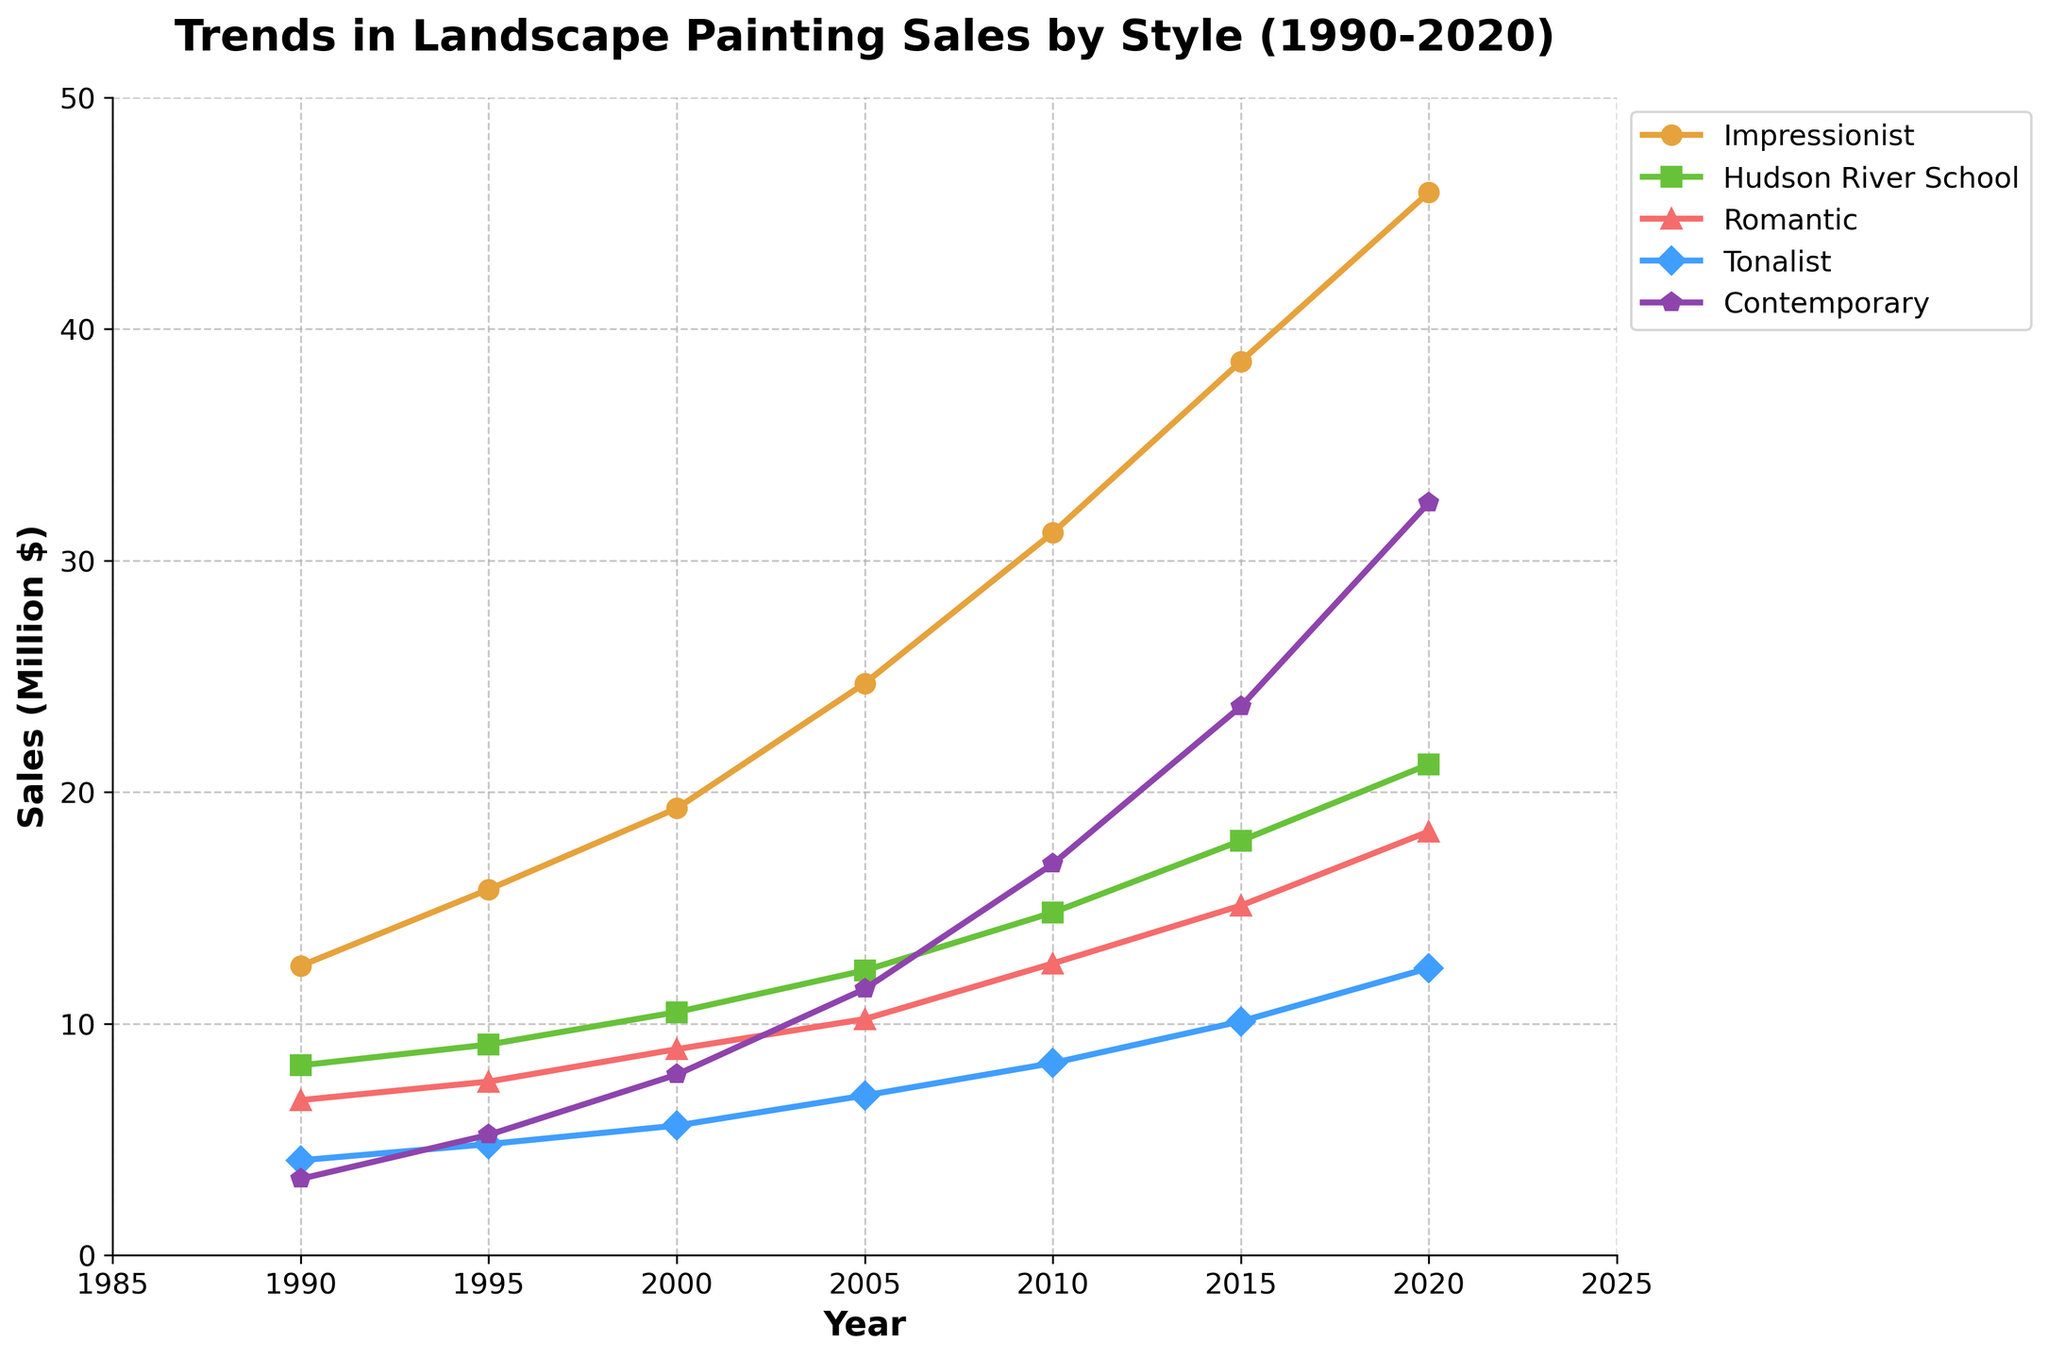What is the overall trend in sales for the Contemporary style from 1990 to 2020? From the figure, the line for Contemporary style shows a consistent upward trend from 1990 to 2020. This indicates that the sales for Contemporary landscape paintings have increased over the past three decades.
Answer: Increasing Which style had the highest sales in 2005? In the year 2005, the height of the Impressionist style line is the highest among all styles on the plot. This shows that Impressionist landscape paintings had the highest sales in that year.
Answer: Impressionist What is the difference in sales between the Hudson River School and Tonalist styles in 2015? For 2015, the sales for Hudson River School is approximately 17.9 million dollars, and for Tonalist, it is approximately 10.1 million dollars. The difference is 17.9 - 10.1 = 7.8 million dollars.
Answer: 7.8 million dollars Which style experienced the greatest increase in sales from 1990 to 2020? To find the greatest increase, subtract the 1990 values from the 2020 values for each style: Impressionist (45.9 - 12.5 = 33.4), Hudson River School (21.2 - 8.2 = 13.0), Romantic (18.3 - 6.7 = 11.6), Tonalist (12.4 - 4.1 = 8.3), Contemporary (32.5 - 3.3 = 29.2). The Impressionist style has the highest increase in sales with 33.4 million dollars.
Answer: Impressionist In which year do sales for the Tonalist style first exceed 10 million dollars? The Tonalist line exceeds the 10 million dollar mark slightly above the 10 million dollar line in the year 2015.
Answer: 2015 How do the sales of Romantic and Hudson River School styles compare in 2000? In the year 2000, the Romantic sales are approximately 8.9 million dollars and the Hudson River School sales are approximately 10.5 million dollars. The Hudson River School sales are higher than Romantic.
Answer: Hudson River School What are the average sales for the Romantic style over the three decades? The sales for Romantic style are 6.7, 7.5, 8.9, 10.2, 12.6, 15.1, and 18.3 over the years. Adding these values together gives 79.3, and dividing this sum by 7 (the number of years) results in approximately 11.3.
Answer: 11.3 million dollars Which three styles show the clearest upward trend over the period from 1990 to 2020? By examining the lines, Impressionist, Hudson River School, and Contemporary styles show a clear and consistent upward trend over the period.
Answer: Impressionist, Hudson River School, and Contemporary 